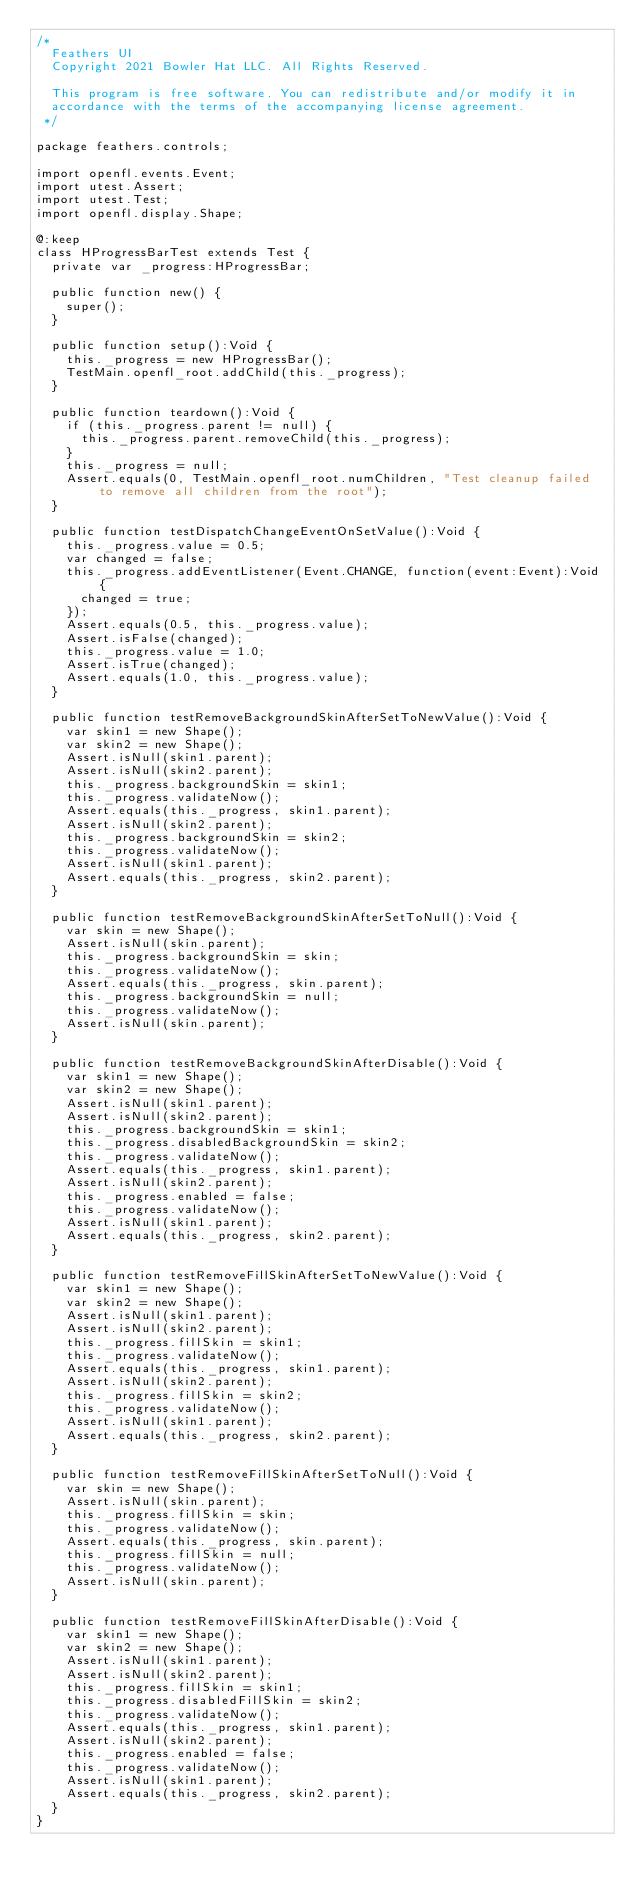<code> <loc_0><loc_0><loc_500><loc_500><_Haxe_>/*
	Feathers UI
	Copyright 2021 Bowler Hat LLC. All Rights Reserved.

	This program is free software. You can redistribute and/or modify it in
	accordance with the terms of the accompanying license agreement.
 */

package feathers.controls;

import openfl.events.Event;
import utest.Assert;
import utest.Test;
import openfl.display.Shape;

@:keep
class HProgressBarTest extends Test {
	private var _progress:HProgressBar;

	public function new() {
		super();
	}

	public function setup():Void {
		this._progress = new HProgressBar();
		TestMain.openfl_root.addChild(this._progress);
	}

	public function teardown():Void {
		if (this._progress.parent != null) {
			this._progress.parent.removeChild(this._progress);
		}
		this._progress = null;
		Assert.equals(0, TestMain.openfl_root.numChildren, "Test cleanup failed to remove all children from the root");
	}

	public function testDispatchChangeEventOnSetValue():Void {
		this._progress.value = 0.5;
		var changed = false;
		this._progress.addEventListener(Event.CHANGE, function(event:Event):Void {
			changed = true;
		});
		Assert.equals(0.5, this._progress.value);
		Assert.isFalse(changed);
		this._progress.value = 1.0;
		Assert.isTrue(changed);
		Assert.equals(1.0, this._progress.value);
	}

	public function testRemoveBackgroundSkinAfterSetToNewValue():Void {
		var skin1 = new Shape();
		var skin2 = new Shape();
		Assert.isNull(skin1.parent);
		Assert.isNull(skin2.parent);
		this._progress.backgroundSkin = skin1;
		this._progress.validateNow();
		Assert.equals(this._progress, skin1.parent);
		Assert.isNull(skin2.parent);
		this._progress.backgroundSkin = skin2;
		this._progress.validateNow();
		Assert.isNull(skin1.parent);
		Assert.equals(this._progress, skin2.parent);
	}

	public function testRemoveBackgroundSkinAfterSetToNull():Void {
		var skin = new Shape();
		Assert.isNull(skin.parent);
		this._progress.backgroundSkin = skin;
		this._progress.validateNow();
		Assert.equals(this._progress, skin.parent);
		this._progress.backgroundSkin = null;
		this._progress.validateNow();
		Assert.isNull(skin.parent);
	}

	public function testRemoveBackgroundSkinAfterDisable():Void {
		var skin1 = new Shape();
		var skin2 = new Shape();
		Assert.isNull(skin1.parent);
		Assert.isNull(skin2.parent);
		this._progress.backgroundSkin = skin1;
		this._progress.disabledBackgroundSkin = skin2;
		this._progress.validateNow();
		Assert.equals(this._progress, skin1.parent);
		Assert.isNull(skin2.parent);
		this._progress.enabled = false;
		this._progress.validateNow();
		Assert.isNull(skin1.parent);
		Assert.equals(this._progress, skin2.parent);
	}

	public function testRemoveFillSkinAfterSetToNewValue():Void {
		var skin1 = new Shape();
		var skin2 = new Shape();
		Assert.isNull(skin1.parent);
		Assert.isNull(skin2.parent);
		this._progress.fillSkin = skin1;
		this._progress.validateNow();
		Assert.equals(this._progress, skin1.parent);
		Assert.isNull(skin2.parent);
		this._progress.fillSkin = skin2;
		this._progress.validateNow();
		Assert.isNull(skin1.parent);
		Assert.equals(this._progress, skin2.parent);
	}

	public function testRemoveFillSkinAfterSetToNull():Void {
		var skin = new Shape();
		Assert.isNull(skin.parent);
		this._progress.fillSkin = skin;
		this._progress.validateNow();
		Assert.equals(this._progress, skin.parent);
		this._progress.fillSkin = null;
		this._progress.validateNow();
		Assert.isNull(skin.parent);
	}

	public function testRemoveFillSkinAfterDisable():Void {
		var skin1 = new Shape();
		var skin2 = new Shape();
		Assert.isNull(skin1.parent);
		Assert.isNull(skin2.parent);
		this._progress.fillSkin = skin1;
		this._progress.disabledFillSkin = skin2;
		this._progress.validateNow();
		Assert.equals(this._progress, skin1.parent);
		Assert.isNull(skin2.parent);
		this._progress.enabled = false;
		this._progress.validateNow();
		Assert.isNull(skin1.parent);
		Assert.equals(this._progress, skin2.parent);
	}
}
</code> 